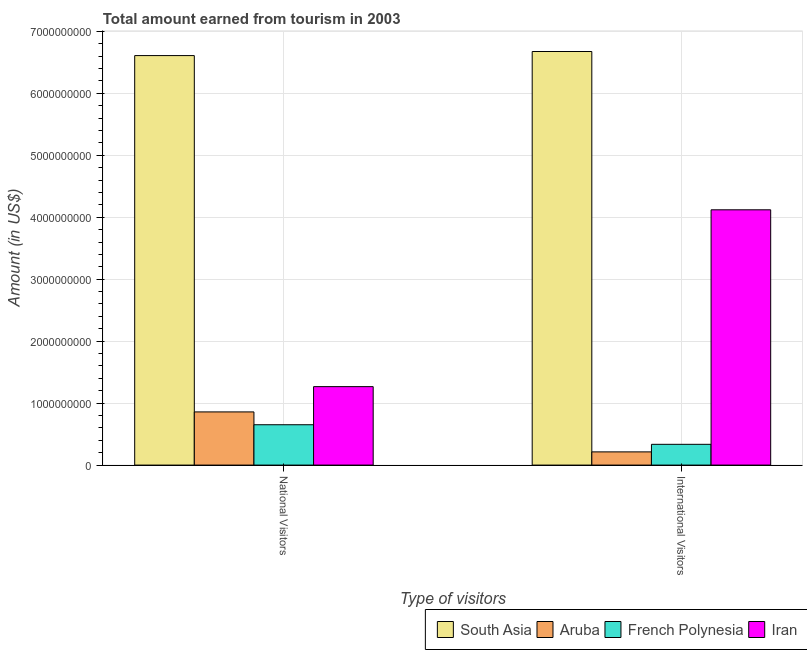How many different coloured bars are there?
Ensure brevity in your answer.  4. How many groups of bars are there?
Keep it short and to the point. 2. How many bars are there on the 1st tick from the left?
Make the answer very short. 4. How many bars are there on the 2nd tick from the right?
Give a very brief answer. 4. What is the label of the 1st group of bars from the left?
Make the answer very short. National Visitors. What is the amount earned from national visitors in French Polynesia?
Give a very brief answer. 6.51e+08. Across all countries, what is the maximum amount earned from international visitors?
Your answer should be very brief. 6.67e+09. Across all countries, what is the minimum amount earned from international visitors?
Your answer should be very brief. 2.13e+08. In which country was the amount earned from international visitors maximum?
Offer a terse response. South Asia. In which country was the amount earned from international visitors minimum?
Make the answer very short. Aruba. What is the total amount earned from international visitors in the graph?
Give a very brief answer. 1.13e+1. What is the difference between the amount earned from national visitors in French Polynesia and that in Iran?
Provide a succinct answer. -6.15e+08. What is the difference between the amount earned from international visitors in Iran and the amount earned from national visitors in South Asia?
Offer a terse response. -2.49e+09. What is the average amount earned from international visitors per country?
Your answer should be compact. 2.84e+09. What is the difference between the amount earned from national visitors and amount earned from international visitors in Aruba?
Offer a very short reply. 6.45e+08. In how many countries, is the amount earned from national visitors greater than 6200000000 US$?
Your answer should be compact. 1. What is the ratio of the amount earned from international visitors in South Asia to that in Aruba?
Your response must be concise. 31.34. In how many countries, is the amount earned from national visitors greater than the average amount earned from national visitors taken over all countries?
Your answer should be compact. 1. What does the 1st bar from the right in International Visitors represents?
Provide a short and direct response. Iran. Are all the bars in the graph horizontal?
Make the answer very short. No. What is the difference between two consecutive major ticks on the Y-axis?
Provide a short and direct response. 1.00e+09. Does the graph contain any zero values?
Provide a short and direct response. No. How are the legend labels stacked?
Your answer should be very brief. Horizontal. What is the title of the graph?
Your response must be concise. Total amount earned from tourism in 2003. What is the label or title of the X-axis?
Offer a very short reply. Type of visitors. What is the label or title of the Y-axis?
Provide a short and direct response. Amount (in US$). What is the Amount (in US$) of South Asia in National Visitors?
Provide a short and direct response. 6.61e+09. What is the Amount (in US$) of Aruba in National Visitors?
Offer a very short reply. 8.58e+08. What is the Amount (in US$) of French Polynesia in National Visitors?
Offer a very short reply. 6.51e+08. What is the Amount (in US$) of Iran in National Visitors?
Your answer should be compact. 1.27e+09. What is the Amount (in US$) in South Asia in International Visitors?
Your answer should be very brief. 6.67e+09. What is the Amount (in US$) of Aruba in International Visitors?
Offer a very short reply. 2.13e+08. What is the Amount (in US$) in French Polynesia in International Visitors?
Your answer should be very brief. 3.35e+08. What is the Amount (in US$) of Iran in International Visitors?
Provide a succinct answer. 4.12e+09. Across all Type of visitors, what is the maximum Amount (in US$) in South Asia?
Offer a very short reply. 6.67e+09. Across all Type of visitors, what is the maximum Amount (in US$) in Aruba?
Your response must be concise. 8.58e+08. Across all Type of visitors, what is the maximum Amount (in US$) in French Polynesia?
Offer a terse response. 6.51e+08. Across all Type of visitors, what is the maximum Amount (in US$) of Iran?
Ensure brevity in your answer.  4.12e+09. Across all Type of visitors, what is the minimum Amount (in US$) of South Asia?
Provide a short and direct response. 6.61e+09. Across all Type of visitors, what is the minimum Amount (in US$) in Aruba?
Your answer should be very brief. 2.13e+08. Across all Type of visitors, what is the minimum Amount (in US$) of French Polynesia?
Offer a very short reply. 3.35e+08. Across all Type of visitors, what is the minimum Amount (in US$) in Iran?
Ensure brevity in your answer.  1.27e+09. What is the total Amount (in US$) of South Asia in the graph?
Keep it short and to the point. 1.33e+1. What is the total Amount (in US$) in Aruba in the graph?
Keep it short and to the point. 1.07e+09. What is the total Amount (in US$) in French Polynesia in the graph?
Give a very brief answer. 9.86e+08. What is the total Amount (in US$) in Iran in the graph?
Offer a terse response. 5.39e+09. What is the difference between the Amount (in US$) of South Asia in National Visitors and that in International Visitors?
Provide a succinct answer. -6.58e+07. What is the difference between the Amount (in US$) in Aruba in National Visitors and that in International Visitors?
Make the answer very short. 6.45e+08. What is the difference between the Amount (in US$) of French Polynesia in National Visitors and that in International Visitors?
Your answer should be compact. 3.16e+08. What is the difference between the Amount (in US$) of Iran in National Visitors and that in International Visitors?
Offer a very short reply. -2.85e+09. What is the difference between the Amount (in US$) of South Asia in National Visitors and the Amount (in US$) of Aruba in International Visitors?
Provide a short and direct response. 6.40e+09. What is the difference between the Amount (in US$) of South Asia in National Visitors and the Amount (in US$) of French Polynesia in International Visitors?
Make the answer very short. 6.27e+09. What is the difference between the Amount (in US$) of South Asia in National Visitors and the Amount (in US$) of Iran in International Visitors?
Provide a short and direct response. 2.49e+09. What is the difference between the Amount (in US$) of Aruba in National Visitors and the Amount (in US$) of French Polynesia in International Visitors?
Your answer should be very brief. 5.23e+08. What is the difference between the Amount (in US$) of Aruba in National Visitors and the Amount (in US$) of Iran in International Visitors?
Offer a very short reply. -3.26e+09. What is the difference between the Amount (in US$) of French Polynesia in National Visitors and the Amount (in US$) of Iran in International Visitors?
Give a very brief answer. -3.47e+09. What is the average Amount (in US$) in South Asia per Type of visitors?
Give a very brief answer. 6.64e+09. What is the average Amount (in US$) of Aruba per Type of visitors?
Make the answer very short. 5.36e+08. What is the average Amount (in US$) of French Polynesia per Type of visitors?
Give a very brief answer. 4.93e+08. What is the average Amount (in US$) of Iran per Type of visitors?
Provide a succinct answer. 2.69e+09. What is the difference between the Amount (in US$) of South Asia and Amount (in US$) of Aruba in National Visitors?
Offer a terse response. 5.75e+09. What is the difference between the Amount (in US$) of South Asia and Amount (in US$) of French Polynesia in National Visitors?
Provide a short and direct response. 5.96e+09. What is the difference between the Amount (in US$) of South Asia and Amount (in US$) of Iran in National Visitors?
Your answer should be very brief. 5.34e+09. What is the difference between the Amount (in US$) of Aruba and Amount (in US$) of French Polynesia in National Visitors?
Your answer should be very brief. 2.07e+08. What is the difference between the Amount (in US$) in Aruba and Amount (in US$) in Iran in National Visitors?
Make the answer very short. -4.08e+08. What is the difference between the Amount (in US$) in French Polynesia and Amount (in US$) in Iran in National Visitors?
Your answer should be very brief. -6.15e+08. What is the difference between the Amount (in US$) in South Asia and Amount (in US$) in Aruba in International Visitors?
Your response must be concise. 6.46e+09. What is the difference between the Amount (in US$) in South Asia and Amount (in US$) in French Polynesia in International Visitors?
Provide a short and direct response. 6.34e+09. What is the difference between the Amount (in US$) in South Asia and Amount (in US$) in Iran in International Visitors?
Offer a very short reply. 2.55e+09. What is the difference between the Amount (in US$) of Aruba and Amount (in US$) of French Polynesia in International Visitors?
Provide a succinct answer. -1.22e+08. What is the difference between the Amount (in US$) of Aruba and Amount (in US$) of Iran in International Visitors?
Make the answer very short. -3.91e+09. What is the difference between the Amount (in US$) in French Polynesia and Amount (in US$) in Iran in International Visitors?
Offer a terse response. -3.78e+09. What is the ratio of the Amount (in US$) in South Asia in National Visitors to that in International Visitors?
Make the answer very short. 0.99. What is the ratio of the Amount (in US$) in Aruba in National Visitors to that in International Visitors?
Ensure brevity in your answer.  4.03. What is the ratio of the Amount (in US$) of French Polynesia in National Visitors to that in International Visitors?
Offer a terse response. 1.94. What is the ratio of the Amount (in US$) in Iran in National Visitors to that in International Visitors?
Keep it short and to the point. 0.31. What is the difference between the highest and the second highest Amount (in US$) of South Asia?
Your response must be concise. 6.58e+07. What is the difference between the highest and the second highest Amount (in US$) of Aruba?
Keep it short and to the point. 6.45e+08. What is the difference between the highest and the second highest Amount (in US$) in French Polynesia?
Your response must be concise. 3.16e+08. What is the difference between the highest and the second highest Amount (in US$) in Iran?
Keep it short and to the point. 2.85e+09. What is the difference between the highest and the lowest Amount (in US$) in South Asia?
Your answer should be compact. 6.58e+07. What is the difference between the highest and the lowest Amount (in US$) in Aruba?
Ensure brevity in your answer.  6.45e+08. What is the difference between the highest and the lowest Amount (in US$) of French Polynesia?
Provide a short and direct response. 3.16e+08. What is the difference between the highest and the lowest Amount (in US$) of Iran?
Your answer should be compact. 2.85e+09. 